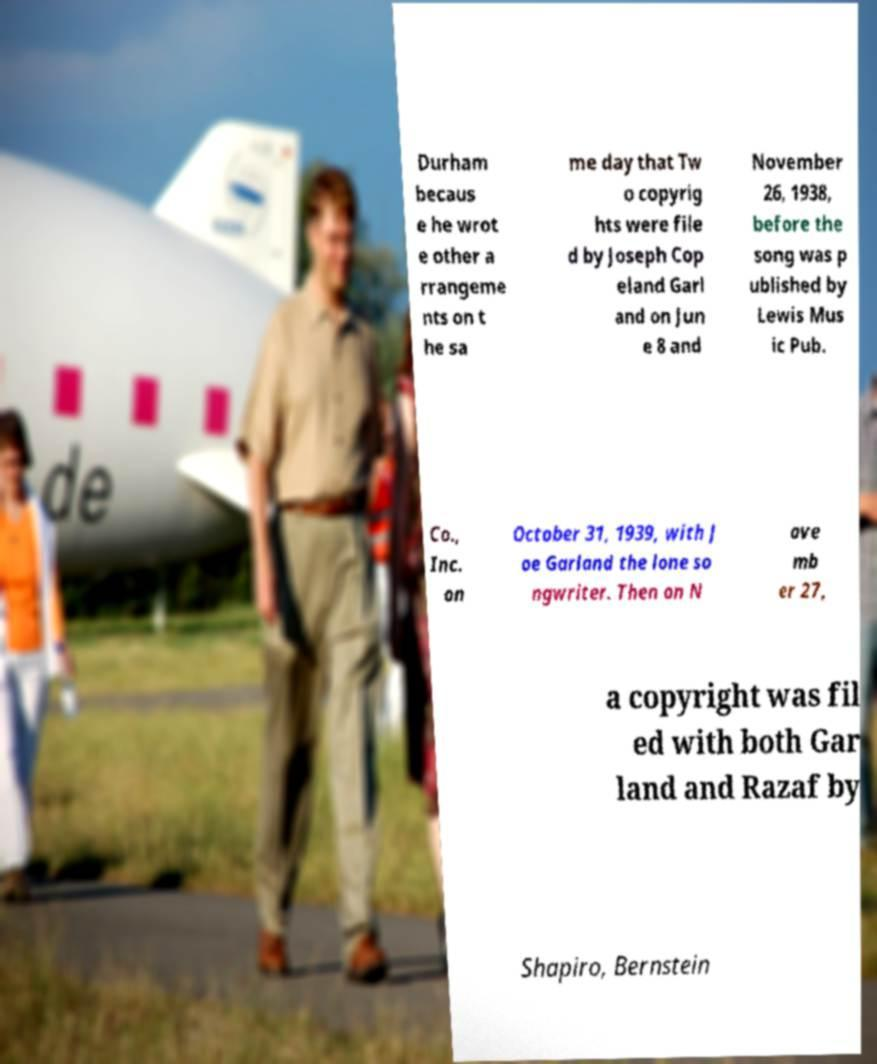Please read and relay the text visible in this image. What does it say? Durham becaus e he wrot e other a rrangeme nts on t he sa me day that Tw o copyrig hts were file d by Joseph Cop eland Garl and on Jun e 8 and November 26, 1938, before the song was p ublished by Lewis Mus ic Pub. Co., Inc. on October 31, 1939, with J oe Garland the lone so ngwriter. Then on N ove mb er 27, a copyright was fil ed with both Gar land and Razaf by Shapiro, Bernstein 